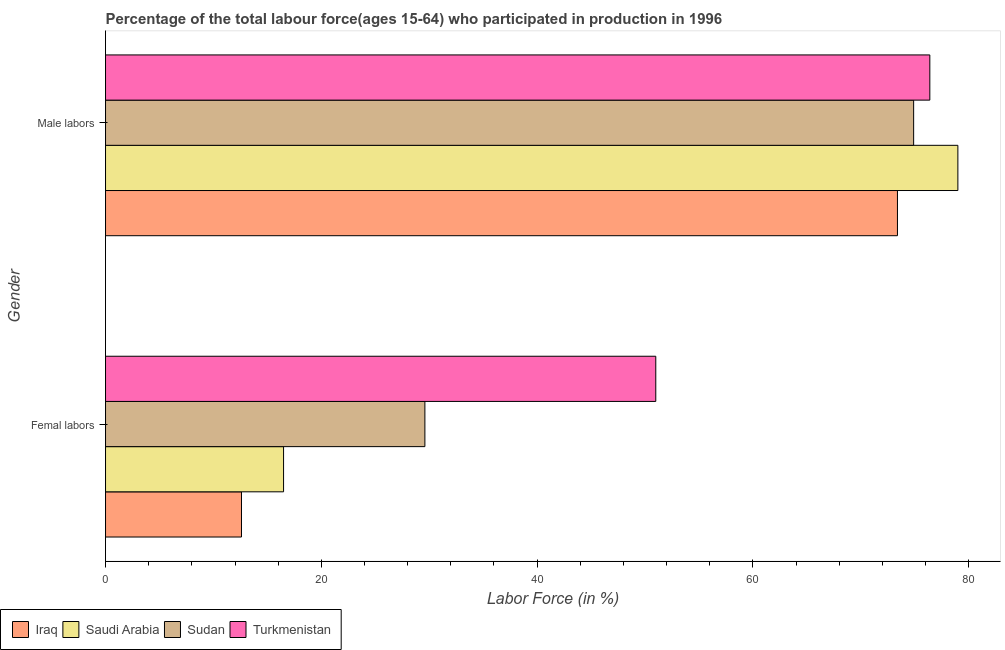How many different coloured bars are there?
Keep it short and to the point. 4. Are the number of bars on each tick of the Y-axis equal?
Offer a very short reply. Yes. What is the label of the 2nd group of bars from the top?
Provide a succinct answer. Femal labors. What is the percentage of female labor force in Iraq?
Your response must be concise. 12.6. Across all countries, what is the maximum percentage of female labor force?
Your response must be concise. 51. Across all countries, what is the minimum percentage of male labour force?
Give a very brief answer. 73.4. In which country was the percentage of female labor force maximum?
Provide a short and direct response. Turkmenistan. In which country was the percentage of male labour force minimum?
Keep it short and to the point. Iraq. What is the total percentage of male labour force in the graph?
Your answer should be very brief. 303.7. What is the difference between the percentage of male labour force in Sudan and the percentage of female labor force in Iraq?
Provide a short and direct response. 62.3. What is the average percentage of male labour force per country?
Make the answer very short. 75.93. What is the difference between the percentage of female labor force and percentage of male labour force in Saudi Arabia?
Your response must be concise. -62.5. In how many countries, is the percentage of female labor force greater than 52 %?
Your answer should be very brief. 0. What is the ratio of the percentage of female labor force in Sudan to that in Saudi Arabia?
Your response must be concise. 1.79. Is the percentage of male labour force in Saudi Arabia less than that in Iraq?
Your response must be concise. No. In how many countries, is the percentage of male labour force greater than the average percentage of male labour force taken over all countries?
Keep it short and to the point. 2. What does the 3rd bar from the top in Femal labors represents?
Provide a succinct answer. Saudi Arabia. What does the 3rd bar from the bottom in Femal labors represents?
Provide a short and direct response. Sudan. What is the difference between two consecutive major ticks on the X-axis?
Offer a very short reply. 20. Are the values on the major ticks of X-axis written in scientific E-notation?
Offer a very short reply. No. How are the legend labels stacked?
Your response must be concise. Horizontal. What is the title of the graph?
Give a very brief answer. Percentage of the total labour force(ages 15-64) who participated in production in 1996. What is the label or title of the X-axis?
Offer a very short reply. Labor Force (in %). What is the label or title of the Y-axis?
Your answer should be compact. Gender. What is the Labor Force (in %) in Iraq in Femal labors?
Provide a succinct answer. 12.6. What is the Labor Force (in %) in Sudan in Femal labors?
Keep it short and to the point. 29.6. What is the Labor Force (in %) of Turkmenistan in Femal labors?
Offer a very short reply. 51. What is the Labor Force (in %) in Iraq in Male labors?
Provide a short and direct response. 73.4. What is the Labor Force (in %) in Saudi Arabia in Male labors?
Give a very brief answer. 79. What is the Labor Force (in %) in Sudan in Male labors?
Your answer should be very brief. 74.9. What is the Labor Force (in %) in Turkmenistan in Male labors?
Keep it short and to the point. 76.4. Across all Gender, what is the maximum Labor Force (in %) in Iraq?
Ensure brevity in your answer.  73.4. Across all Gender, what is the maximum Labor Force (in %) in Saudi Arabia?
Provide a short and direct response. 79. Across all Gender, what is the maximum Labor Force (in %) in Sudan?
Your response must be concise. 74.9. Across all Gender, what is the maximum Labor Force (in %) in Turkmenistan?
Your response must be concise. 76.4. Across all Gender, what is the minimum Labor Force (in %) in Iraq?
Your answer should be very brief. 12.6. Across all Gender, what is the minimum Labor Force (in %) of Saudi Arabia?
Your answer should be compact. 16.5. Across all Gender, what is the minimum Labor Force (in %) of Sudan?
Give a very brief answer. 29.6. Across all Gender, what is the minimum Labor Force (in %) of Turkmenistan?
Offer a terse response. 51. What is the total Labor Force (in %) of Saudi Arabia in the graph?
Make the answer very short. 95.5. What is the total Labor Force (in %) in Sudan in the graph?
Offer a very short reply. 104.5. What is the total Labor Force (in %) of Turkmenistan in the graph?
Provide a succinct answer. 127.4. What is the difference between the Labor Force (in %) of Iraq in Femal labors and that in Male labors?
Give a very brief answer. -60.8. What is the difference between the Labor Force (in %) in Saudi Arabia in Femal labors and that in Male labors?
Offer a very short reply. -62.5. What is the difference between the Labor Force (in %) of Sudan in Femal labors and that in Male labors?
Your answer should be very brief. -45.3. What is the difference between the Labor Force (in %) of Turkmenistan in Femal labors and that in Male labors?
Give a very brief answer. -25.4. What is the difference between the Labor Force (in %) of Iraq in Femal labors and the Labor Force (in %) of Saudi Arabia in Male labors?
Make the answer very short. -66.4. What is the difference between the Labor Force (in %) in Iraq in Femal labors and the Labor Force (in %) in Sudan in Male labors?
Your answer should be very brief. -62.3. What is the difference between the Labor Force (in %) of Iraq in Femal labors and the Labor Force (in %) of Turkmenistan in Male labors?
Provide a succinct answer. -63.8. What is the difference between the Labor Force (in %) of Saudi Arabia in Femal labors and the Labor Force (in %) of Sudan in Male labors?
Your answer should be compact. -58.4. What is the difference between the Labor Force (in %) of Saudi Arabia in Femal labors and the Labor Force (in %) of Turkmenistan in Male labors?
Your response must be concise. -59.9. What is the difference between the Labor Force (in %) of Sudan in Femal labors and the Labor Force (in %) of Turkmenistan in Male labors?
Offer a very short reply. -46.8. What is the average Labor Force (in %) of Iraq per Gender?
Make the answer very short. 43. What is the average Labor Force (in %) in Saudi Arabia per Gender?
Your response must be concise. 47.75. What is the average Labor Force (in %) of Sudan per Gender?
Offer a terse response. 52.25. What is the average Labor Force (in %) of Turkmenistan per Gender?
Your answer should be very brief. 63.7. What is the difference between the Labor Force (in %) of Iraq and Labor Force (in %) of Sudan in Femal labors?
Give a very brief answer. -17. What is the difference between the Labor Force (in %) of Iraq and Labor Force (in %) of Turkmenistan in Femal labors?
Make the answer very short. -38.4. What is the difference between the Labor Force (in %) in Saudi Arabia and Labor Force (in %) in Sudan in Femal labors?
Ensure brevity in your answer.  -13.1. What is the difference between the Labor Force (in %) in Saudi Arabia and Labor Force (in %) in Turkmenistan in Femal labors?
Provide a succinct answer. -34.5. What is the difference between the Labor Force (in %) of Sudan and Labor Force (in %) of Turkmenistan in Femal labors?
Provide a short and direct response. -21.4. What is the difference between the Labor Force (in %) of Iraq and Labor Force (in %) of Turkmenistan in Male labors?
Your answer should be compact. -3. What is the difference between the Labor Force (in %) of Saudi Arabia and Labor Force (in %) of Sudan in Male labors?
Provide a succinct answer. 4.1. What is the difference between the Labor Force (in %) of Saudi Arabia and Labor Force (in %) of Turkmenistan in Male labors?
Ensure brevity in your answer.  2.6. What is the difference between the Labor Force (in %) in Sudan and Labor Force (in %) in Turkmenistan in Male labors?
Give a very brief answer. -1.5. What is the ratio of the Labor Force (in %) of Iraq in Femal labors to that in Male labors?
Ensure brevity in your answer.  0.17. What is the ratio of the Labor Force (in %) in Saudi Arabia in Femal labors to that in Male labors?
Your answer should be compact. 0.21. What is the ratio of the Labor Force (in %) of Sudan in Femal labors to that in Male labors?
Offer a terse response. 0.4. What is the ratio of the Labor Force (in %) of Turkmenistan in Femal labors to that in Male labors?
Ensure brevity in your answer.  0.67. What is the difference between the highest and the second highest Labor Force (in %) in Iraq?
Provide a succinct answer. 60.8. What is the difference between the highest and the second highest Labor Force (in %) in Saudi Arabia?
Keep it short and to the point. 62.5. What is the difference between the highest and the second highest Labor Force (in %) in Sudan?
Ensure brevity in your answer.  45.3. What is the difference between the highest and the second highest Labor Force (in %) in Turkmenistan?
Keep it short and to the point. 25.4. What is the difference between the highest and the lowest Labor Force (in %) in Iraq?
Offer a terse response. 60.8. What is the difference between the highest and the lowest Labor Force (in %) in Saudi Arabia?
Your answer should be compact. 62.5. What is the difference between the highest and the lowest Labor Force (in %) in Sudan?
Give a very brief answer. 45.3. What is the difference between the highest and the lowest Labor Force (in %) in Turkmenistan?
Give a very brief answer. 25.4. 